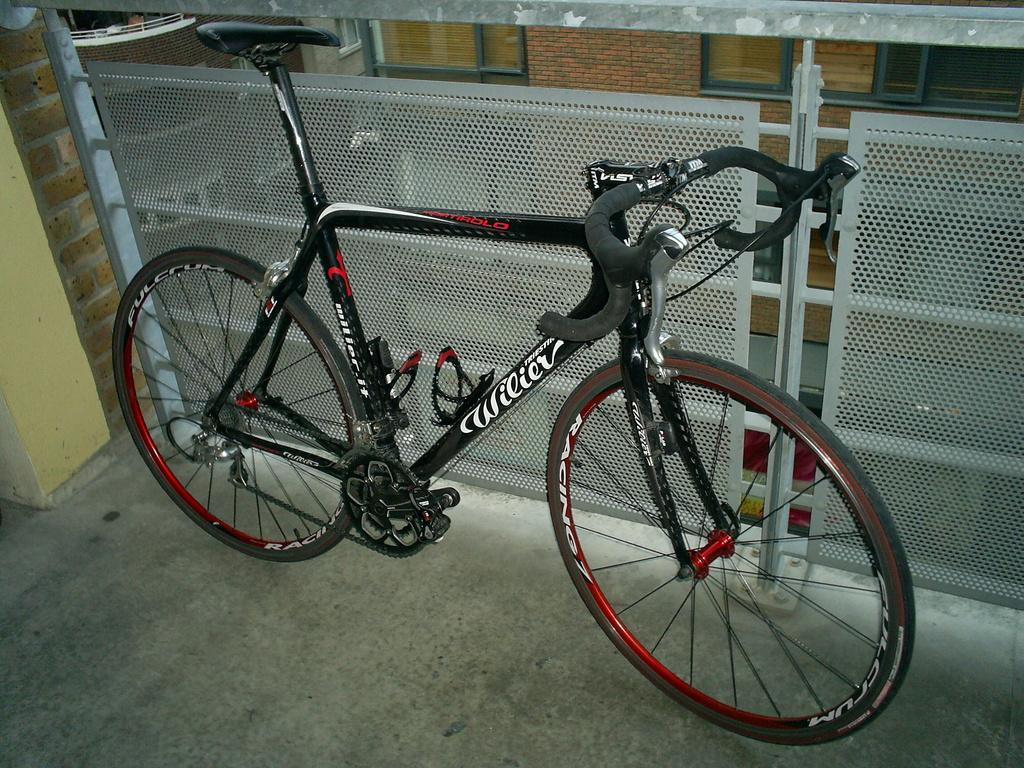What is the main object in the image? There is a bicycle in the image. What type of structure can be seen in the image? There is fencing in the image. What can be seen in the background of the image? There is a wall and a window in the background of the image. What type of pencil is being used to draw on the bicycle in the image? There is no pencil or drawing present on the bicycle in the image. 